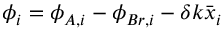Convert formula to latex. <formula><loc_0><loc_0><loc_500><loc_500>\phi _ { i } = \phi _ { A , i } - \phi _ { B r , i } - \delta k \bar { x } _ { i }</formula> 